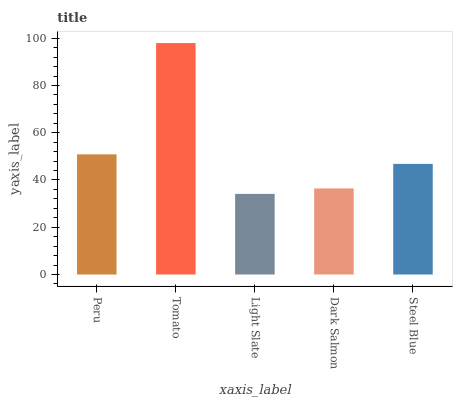Is Light Slate the minimum?
Answer yes or no. Yes. Is Tomato the maximum?
Answer yes or no. Yes. Is Tomato the minimum?
Answer yes or no. No. Is Light Slate the maximum?
Answer yes or no. No. Is Tomato greater than Light Slate?
Answer yes or no. Yes. Is Light Slate less than Tomato?
Answer yes or no. Yes. Is Light Slate greater than Tomato?
Answer yes or no. No. Is Tomato less than Light Slate?
Answer yes or no. No. Is Steel Blue the high median?
Answer yes or no. Yes. Is Steel Blue the low median?
Answer yes or no. Yes. Is Dark Salmon the high median?
Answer yes or no. No. Is Light Slate the low median?
Answer yes or no. No. 